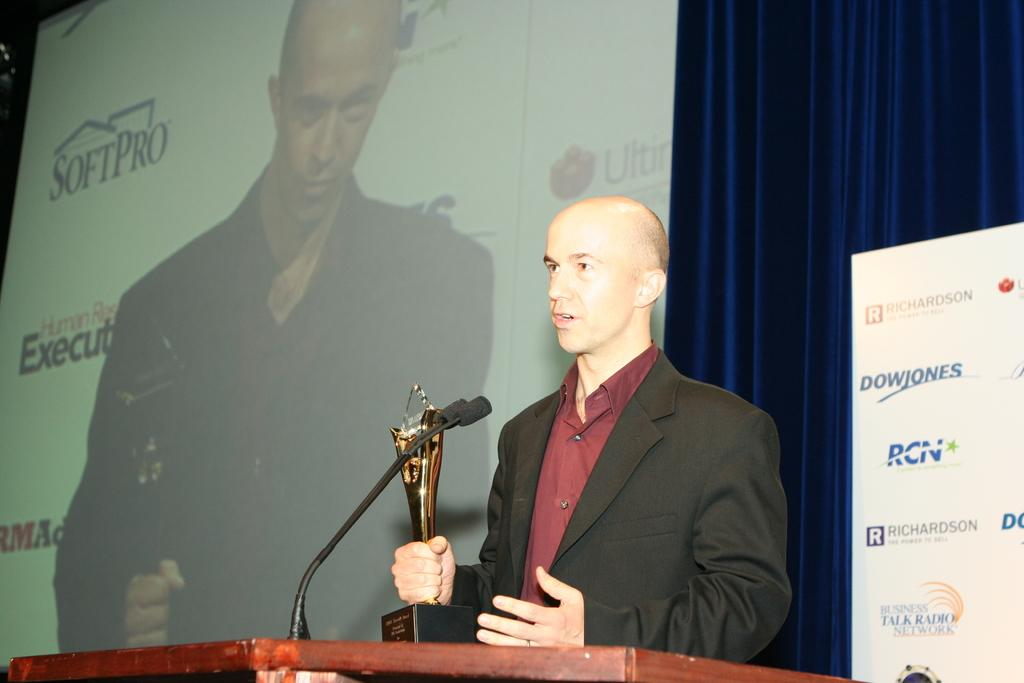What is the man in the image doing? The man is standing near a podium on the right side of the image and speaking into a microphone. What is the man wearing in the image? The man is wearing a black coat in the image. What can be seen on the left side of the image? There is a projector screen on the left side of the image. Can you see any ants crawling on the microphone in the image? There are no ants visible in the image, and they are not crawling on the microphone. How many rings is the man wearing on his fingers in the image? The image does not show the man wearing any rings on his fingers. 